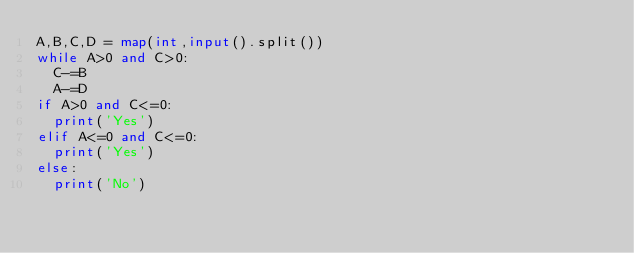Convert code to text. <code><loc_0><loc_0><loc_500><loc_500><_Python_>A,B,C,D = map(int,input().split())
while A>0 and C>0:
  C-=B
  A-=D
if A>0 and C<=0:
  print('Yes')
elif A<=0 and C<=0:
  print('Yes')
else:
  print('No')</code> 